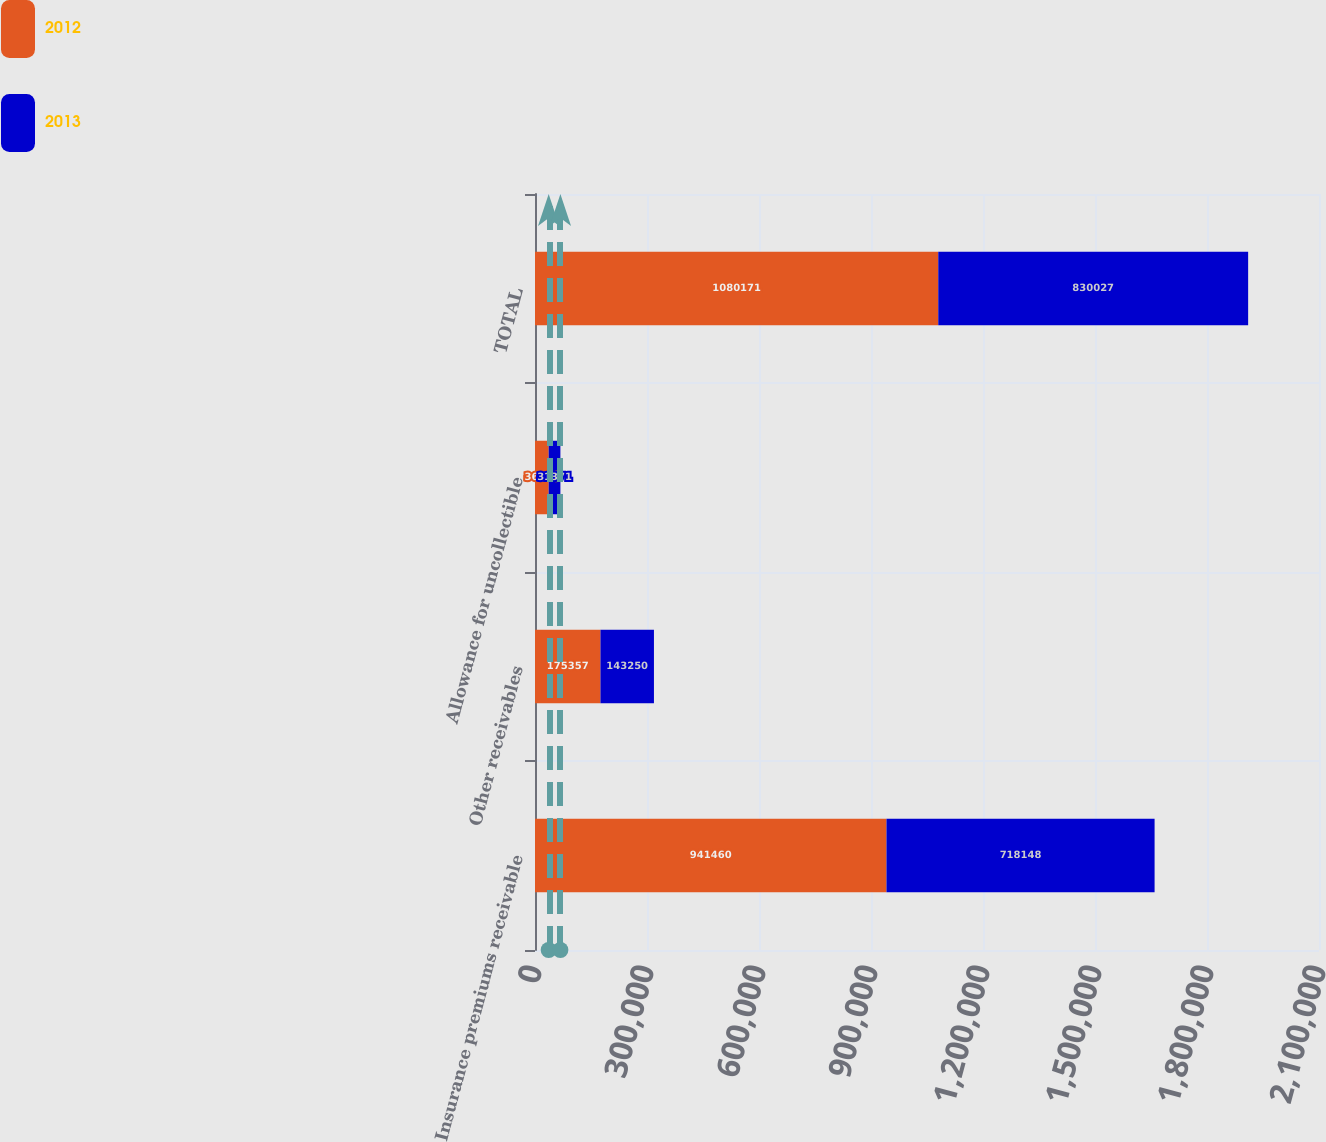Convert chart. <chart><loc_0><loc_0><loc_500><loc_500><stacked_bar_chart><ecel><fcel>Insurance premiums receivable<fcel>Other receivables<fcel>Allowance for uncollectible<fcel>TOTAL<nl><fcel>2012<fcel>941460<fcel>175357<fcel>36646<fcel>1.08017e+06<nl><fcel>2013<fcel>718148<fcel>143250<fcel>31371<fcel>830027<nl></chart> 